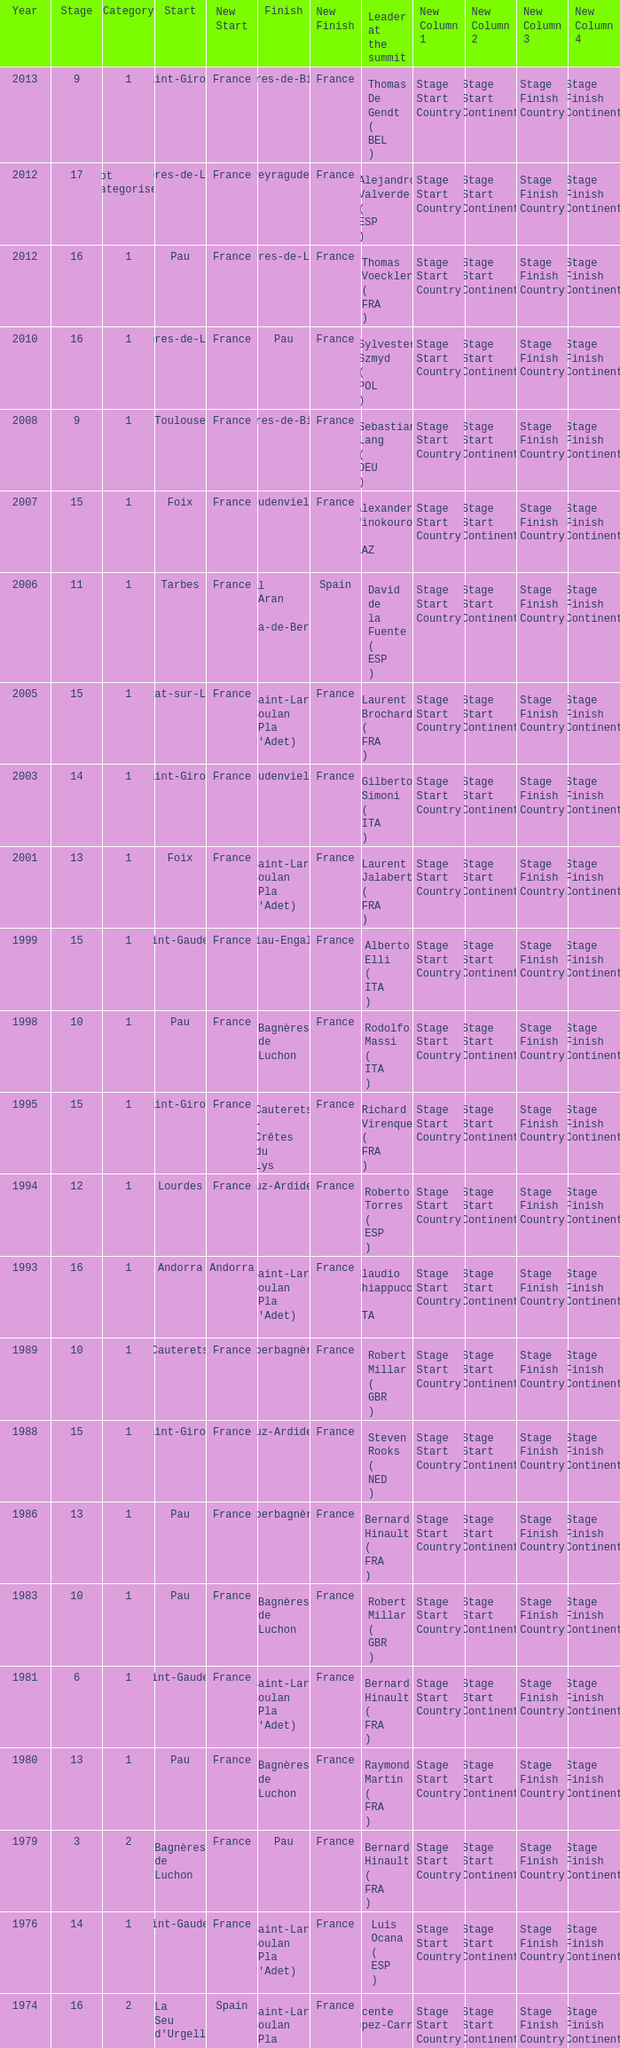What stage has a start of saint-girons in 1988? 15.0. 